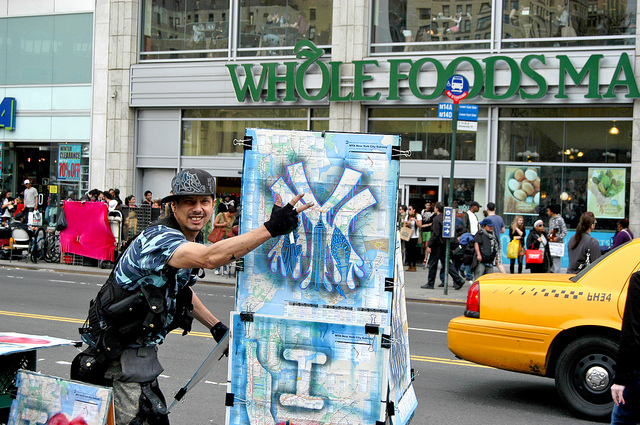<image>What movie is advertised on the taxi? I don't know what movie is advertised on the taxi. There are no clear indications. What movie is advertised on the taxi? It is ambiguous what movie is advertised on the taxi. It can be seen 'godzilla', 'time bandits', 'lord of rings' or 'taxi'. 